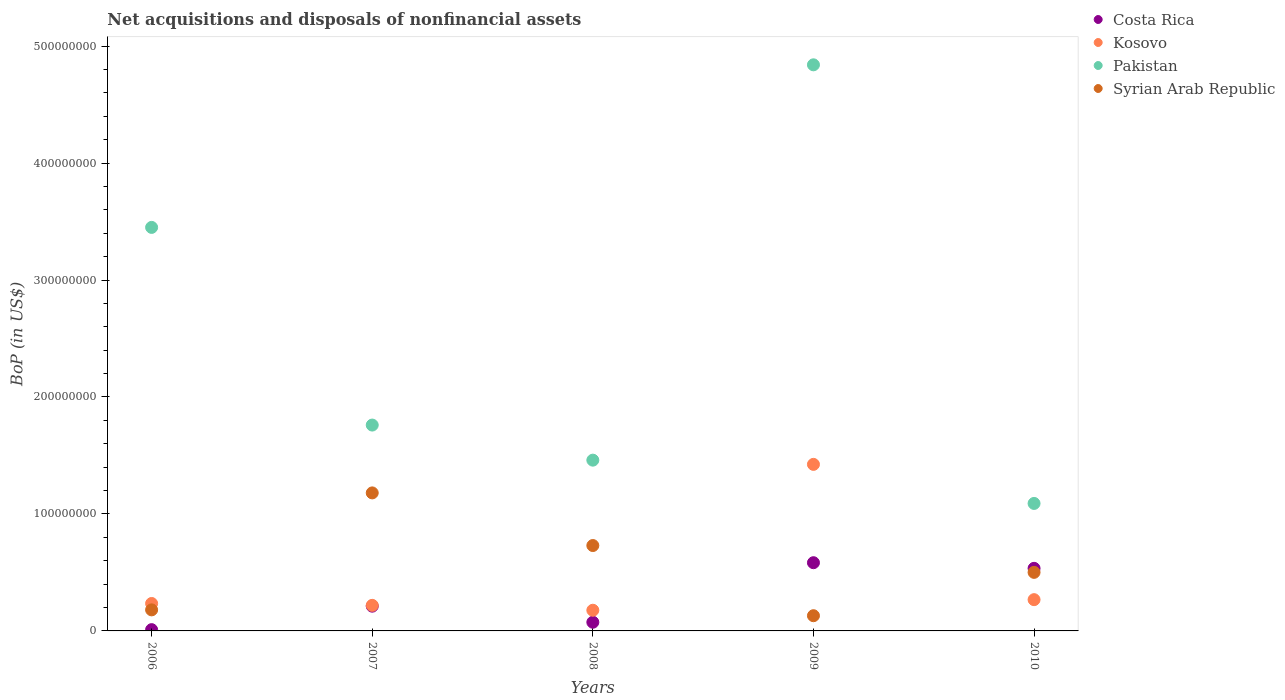How many different coloured dotlines are there?
Give a very brief answer. 4. What is the Balance of Payments in Syrian Arab Republic in 2006?
Offer a terse response. 1.80e+07. Across all years, what is the maximum Balance of Payments in Syrian Arab Republic?
Keep it short and to the point. 1.18e+08. Across all years, what is the minimum Balance of Payments in Pakistan?
Your response must be concise. 1.09e+08. In which year was the Balance of Payments in Pakistan minimum?
Your answer should be very brief. 2010. What is the total Balance of Payments in Syrian Arab Republic in the graph?
Provide a succinct answer. 2.72e+08. What is the difference between the Balance of Payments in Pakistan in 2006 and that in 2008?
Offer a very short reply. 1.99e+08. What is the difference between the Balance of Payments in Syrian Arab Republic in 2009 and the Balance of Payments in Costa Rica in 2007?
Provide a succinct answer. -8.17e+06. What is the average Balance of Payments in Pakistan per year?
Offer a terse response. 2.52e+08. In the year 2007, what is the difference between the Balance of Payments in Kosovo and Balance of Payments in Syrian Arab Republic?
Provide a short and direct response. -9.61e+07. In how many years, is the Balance of Payments in Pakistan greater than 440000000 US$?
Make the answer very short. 1. What is the ratio of the Balance of Payments in Pakistan in 2006 to that in 2008?
Give a very brief answer. 2.36. Is the Balance of Payments in Costa Rica in 2006 less than that in 2007?
Provide a short and direct response. Yes. What is the difference between the highest and the second highest Balance of Payments in Pakistan?
Ensure brevity in your answer.  1.39e+08. What is the difference between the highest and the lowest Balance of Payments in Costa Rica?
Offer a very short reply. 5.72e+07. Is the sum of the Balance of Payments in Costa Rica in 2008 and 2009 greater than the maximum Balance of Payments in Kosovo across all years?
Provide a succinct answer. No. Is it the case that in every year, the sum of the Balance of Payments in Kosovo and Balance of Payments in Costa Rica  is greater than the sum of Balance of Payments in Pakistan and Balance of Payments in Syrian Arab Republic?
Ensure brevity in your answer.  No. How many dotlines are there?
Offer a terse response. 4. Does the graph contain any zero values?
Your answer should be compact. No. Where does the legend appear in the graph?
Offer a very short reply. Top right. How many legend labels are there?
Make the answer very short. 4. How are the legend labels stacked?
Provide a succinct answer. Vertical. What is the title of the graph?
Your answer should be compact. Net acquisitions and disposals of nonfinancial assets. Does "Other small states" appear as one of the legend labels in the graph?
Give a very brief answer. No. What is the label or title of the X-axis?
Offer a very short reply. Years. What is the label or title of the Y-axis?
Give a very brief answer. BoP (in US$). What is the BoP (in US$) of Costa Rica in 2006?
Make the answer very short. 1.09e+06. What is the BoP (in US$) in Kosovo in 2006?
Give a very brief answer. 2.35e+07. What is the BoP (in US$) in Pakistan in 2006?
Keep it short and to the point. 3.45e+08. What is the BoP (in US$) of Syrian Arab Republic in 2006?
Provide a short and direct response. 1.80e+07. What is the BoP (in US$) in Costa Rica in 2007?
Your answer should be very brief. 2.12e+07. What is the BoP (in US$) in Kosovo in 2007?
Your answer should be very brief. 2.19e+07. What is the BoP (in US$) in Pakistan in 2007?
Your response must be concise. 1.76e+08. What is the BoP (in US$) in Syrian Arab Republic in 2007?
Your answer should be very brief. 1.18e+08. What is the BoP (in US$) of Costa Rica in 2008?
Your response must be concise. 7.42e+06. What is the BoP (in US$) of Kosovo in 2008?
Offer a very short reply. 1.77e+07. What is the BoP (in US$) of Pakistan in 2008?
Your answer should be very brief. 1.46e+08. What is the BoP (in US$) in Syrian Arab Republic in 2008?
Make the answer very short. 7.30e+07. What is the BoP (in US$) in Costa Rica in 2009?
Your answer should be compact. 5.83e+07. What is the BoP (in US$) of Kosovo in 2009?
Provide a short and direct response. 1.42e+08. What is the BoP (in US$) of Pakistan in 2009?
Your response must be concise. 4.84e+08. What is the BoP (in US$) in Syrian Arab Republic in 2009?
Keep it short and to the point. 1.30e+07. What is the BoP (in US$) of Costa Rica in 2010?
Your answer should be very brief. 5.35e+07. What is the BoP (in US$) of Kosovo in 2010?
Your response must be concise. 2.67e+07. What is the BoP (in US$) in Pakistan in 2010?
Offer a very short reply. 1.09e+08. What is the BoP (in US$) of Syrian Arab Republic in 2010?
Offer a terse response. 5.01e+07. Across all years, what is the maximum BoP (in US$) of Costa Rica?
Keep it short and to the point. 5.83e+07. Across all years, what is the maximum BoP (in US$) of Kosovo?
Provide a succinct answer. 1.42e+08. Across all years, what is the maximum BoP (in US$) in Pakistan?
Your answer should be compact. 4.84e+08. Across all years, what is the maximum BoP (in US$) of Syrian Arab Republic?
Your answer should be very brief. 1.18e+08. Across all years, what is the minimum BoP (in US$) in Costa Rica?
Offer a very short reply. 1.09e+06. Across all years, what is the minimum BoP (in US$) of Kosovo?
Keep it short and to the point. 1.77e+07. Across all years, what is the minimum BoP (in US$) in Pakistan?
Give a very brief answer. 1.09e+08. Across all years, what is the minimum BoP (in US$) in Syrian Arab Republic?
Give a very brief answer. 1.30e+07. What is the total BoP (in US$) in Costa Rica in the graph?
Your answer should be compact. 1.41e+08. What is the total BoP (in US$) of Kosovo in the graph?
Your answer should be very brief. 2.32e+08. What is the total BoP (in US$) in Pakistan in the graph?
Ensure brevity in your answer.  1.26e+09. What is the total BoP (in US$) in Syrian Arab Republic in the graph?
Offer a very short reply. 2.72e+08. What is the difference between the BoP (in US$) in Costa Rica in 2006 and that in 2007?
Offer a very short reply. -2.01e+07. What is the difference between the BoP (in US$) of Kosovo in 2006 and that in 2007?
Your response must be concise. 1.60e+06. What is the difference between the BoP (in US$) in Pakistan in 2006 and that in 2007?
Your answer should be very brief. 1.69e+08. What is the difference between the BoP (in US$) in Syrian Arab Republic in 2006 and that in 2007?
Make the answer very short. -1.00e+08. What is the difference between the BoP (in US$) in Costa Rica in 2006 and that in 2008?
Your response must be concise. -6.33e+06. What is the difference between the BoP (in US$) in Kosovo in 2006 and that in 2008?
Your answer should be compact. 5.78e+06. What is the difference between the BoP (in US$) in Pakistan in 2006 and that in 2008?
Your answer should be very brief. 1.99e+08. What is the difference between the BoP (in US$) of Syrian Arab Republic in 2006 and that in 2008?
Ensure brevity in your answer.  -5.50e+07. What is the difference between the BoP (in US$) in Costa Rica in 2006 and that in 2009?
Ensure brevity in your answer.  -5.72e+07. What is the difference between the BoP (in US$) of Kosovo in 2006 and that in 2009?
Offer a terse response. -1.19e+08. What is the difference between the BoP (in US$) in Pakistan in 2006 and that in 2009?
Your answer should be compact. -1.39e+08. What is the difference between the BoP (in US$) of Costa Rica in 2006 and that in 2010?
Provide a succinct answer. -5.24e+07. What is the difference between the BoP (in US$) in Kosovo in 2006 and that in 2010?
Give a very brief answer. -3.27e+06. What is the difference between the BoP (in US$) of Pakistan in 2006 and that in 2010?
Provide a short and direct response. 2.36e+08. What is the difference between the BoP (in US$) of Syrian Arab Republic in 2006 and that in 2010?
Keep it short and to the point. -3.21e+07. What is the difference between the BoP (in US$) of Costa Rica in 2007 and that in 2008?
Your answer should be compact. 1.37e+07. What is the difference between the BoP (in US$) in Kosovo in 2007 and that in 2008?
Give a very brief answer. 4.18e+06. What is the difference between the BoP (in US$) in Pakistan in 2007 and that in 2008?
Make the answer very short. 3.00e+07. What is the difference between the BoP (in US$) of Syrian Arab Republic in 2007 and that in 2008?
Offer a terse response. 4.50e+07. What is the difference between the BoP (in US$) of Costa Rica in 2007 and that in 2009?
Your answer should be very brief. -3.72e+07. What is the difference between the BoP (in US$) in Kosovo in 2007 and that in 2009?
Offer a terse response. -1.21e+08. What is the difference between the BoP (in US$) of Pakistan in 2007 and that in 2009?
Your answer should be compact. -3.08e+08. What is the difference between the BoP (in US$) in Syrian Arab Republic in 2007 and that in 2009?
Provide a succinct answer. 1.05e+08. What is the difference between the BoP (in US$) of Costa Rica in 2007 and that in 2010?
Your response must be concise. -3.23e+07. What is the difference between the BoP (in US$) in Kosovo in 2007 and that in 2010?
Your answer should be very brief. -4.87e+06. What is the difference between the BoP (in US$) of Pakistan in 2007 and that in 2010?
Your answer should be very brief. 6.70e+07. What is the difference between the BoP (in US$) of Syrian Arab Republic in 2007 and that in 2010?
Offer a very short reply. 6.79e+07. What is the difference between the BoP (in US$) of Costa Rica in 2008 and that in 2009?
Provide a succinct answer. -5.09e+07. What is the difference between the BoP (in US$) in Kosovo in 2008 and that in 2009?
Offer a terse response. -1.25e+08. What is the difference between the BoP (in US$) of Pakistan in 2008 and that in 2009?
Provide a short and direct response. -3.38e+08. What is the difference between the BoP (in US$) in Syrian Arab Republic in 2008 and that in 2009?
Offer a terse response. 6.00e+07. What is the difference between the BoP (in US$) in Costa Rica in 2008 and that in 2010?
Provide a short and direct response. -4.61e+07. What is the difference between the BoP (in US$) of Kosovo in 2008 and that in 2010?
Offer a terse response. -9.06e+06. What is the difference between the BoP (in US$) in Pakistan in 2008 and that in 2010?
Make the answer very short. 3.70e+07. What is the difference between the BoP (in US$) in Syrian Arab Republic in 2008 and that in 2010?
Provide a short and direct response. 2.29e+07. What is the difference between the BoP (in US$) of Costa Rica in 2009 and that in 2010?
Provide a short and direct response. 4.81e+06. What is the difference between the BoP (in US$) of Kosovo in 2009 and that in 2010?
Your answer should be compact. 1.16e+08. What is the difference between the BoP (in US$) of Pakistan in 2009 and that in 2010?
Your answer should be very brief. 3.75e+08. What is the difference between the BoP (in US$) in Syrian Arab Republic in 2009 and that in 2010?
Ensure brevity in your answer.  -3.71e+07. What is the difference between the BoP (in US$) of Costa Rica in 2006 and the BoP (in US$) of Kosovo in 2007?
Give a very brief answer. -2.08e+07. What is the difference between the BoP (in US$) of Costa Rica in 2006 and the BoP (in US$) of Pakistan in 2007?
Ensure brevity in your answer.  -1.75e+08. What is the difference between the BoP (in US$) in Costa Rica in 2006 and the BoP (in US$) in Syrian Arab Republic in 2007?
Your answer should be very brief. -1.17e+08. What is the difference between the BoP (in US$) in Kosovo in 2006 and the BoP (in US$) in Pakistan in 2007?
Ensure brevity in your answer.  -1.53e+08. What is the difference between the BoP (in US$) of Kosovo in 2006 and the BoP (in US$) of Syrian Arab Republic in 2007?
Offer a very short reply. -9.45e+07. What is the difference between the BoP (in US$) in Pakistan in 2006 and the BoP (in US$) in Syrian Arab Republic in 2007?
Offer a terse response. 2.27e+08. What is the difference between the BoP (in US$) in Costa Rica in 2006 and the BoP (in US$) in Kosovo in 2008?
Ensure brevity in your answer.  -1.66e+07. What is the difference between the BoP (in US$) of Costa Rica in 2006 and the BoP (in US$) of Pakistan in 2008?
Ensure brevity in your answer.  -1.45e+08. What is the difference between the BoP (in US$) in Costa Rica in 2006 and the BoP (in US$) in Syrian Arab Republic in 2008?
Ensure brevity in your answer.  -7.19e+07. What is the difference between the BoP (in US$) in Kosovo in 2006 and the BoP (in US$) in Pakistan in 2008?
Offer a very short reply. -1.23e+08. What is the difference between the BoP (in US$) in Kosovo in 2006 and the BoP (in US$) in Syrian Arab Republic in 2008?
Keep it short and to the point. -4.95e+07. What is the difference between the BoP (in US$) of Pakistan in 2006 and the BoP (in US$) of Syrian Arab Republic in 2008?
Your response must be concise. 2.72e+08. What is the difference between the BoP (in US$) in Costa Rica in 2006 and the BoP (in US$) in Kosovo in 2009?
Provide a short and direct response. -1.41e+08. What is the difference between the BoP (in US$) of Costa Rica in 2006 and the BoP (in US$) of Pakistan in 2009?
Your response must be concise. -4.83e+08. What is the difference between the BoP (in US$) in Costa Rica in 2006 and the BoP (in US$) in Syrian Arab Republic in 2009?
Make the answer very short. -1.19e+07. What is the difference between the BoP (in US$) of Kosovo in 2006 and the BoP (in US$) of Pakistan in 2009?
Your response must be concise. -4.61e+08. What is the difference between the BoP (in US$) of Kosovo in 2006 and the BoP (in US$) of Syrian Arab Republic in 2009?
Offer a very short reply. 1.05e+07. What is the difference between the BoP (in US$) of Pakistan in 2006 and the BoP (in US$) of Syrian Arab Republic in 2009?
Make the answer very short. 3.32e+08. What is the difference between the BoP (in US$) of Costa Rica in 2006 and the BoP (in US$) of Kosovo in 2010?
Give a very brief answer. -2.56e+07. What is the difference between the BoP (in US$) of Costa Rica in 2006 and the BoP (in US$) of Pakistan in 2010?
Ensure brevity in your answer.  -1.08e+08. What is the difference between the BoP (in US$) of Costa Rica in 2006 and the BoP (in US$) of Syrian Arab Republic in 2010?
Your answer should be very brief. -4.90e+07. What is the difference between the BoP (in US$) of Kosovo in 2006 and the BoP (in US$) of Pakistan in 2010?
Offer a very short reply. -8.55e+07. What is the difference between the BoP (in US$) of Kosovo in 2006 and the BoP (in US$) of Syrian Arab Republic in 2010?
Keep it short and to the point. -2.66e+07. What is the difference between the BoP (in US$) of Pakistan in 2006 and the BoP (in US$) of Syrian Arab Republic in 2010?
Offer a terse response. 2.95e+08. What is the difference between the BoP (in US$) in Costa Rica in 2007 and the BoP (in US$) in Kosovo in 2008?
Make the answer very short. 3.49e+06. What is the difference between the BoP (in US$) in Costa Rica in 2007 and the BoP (in US$) in Pakistan in 2008?
Give a very brief answer. -1.25e+08. What is the difference between the BoP (in US$) in Costa Rica in 2007 and the BoP (in US$) in Syrian Arab Republic in 2008?
Make the answer very short. -5.18e+07. What is the difference between the BoP (in US$) of Kosovo in 2007 and the BoP (in US$) of Pakistan in 2008?
Your answer should be compact. -1.24e+08. What is the difference between the BoP (in US$) of Kosovo in 2007 and the BoP (in US$) of Syrian Arab Republic in 2008?
Provide a succinct answer. -5.11e+07. What is the difference between the BoP (in US$) in Pakistan in 2007 and the BoP (in US$) in Syrian Arab Republic in 2008?
Offer a very short reply. 1.03e+08. What is the difference between the BoP (in US$) in Costa Rica in 2007 and the BoP (in US$) in Kosovo in 2009?
Provide a succinct answer. -1.21e+08. What is the difference between the BoP (in US$) in Costa Rica in 2007 and the BoP (in US$) in Pakistan in 2009?
Ensure brevity in your answer.  -4.63e+08. What is the difference between the BoP (in US$) of Costa Rica in 2007 and the BoP (in US$) of Syrian Arab Republic in 2009?
Your answer should be very brief. 8.17e+06. What is the difference between the BoP (in US$) in Kosovo in 2007 and the BoP (in US$) in Pakistan in 2009?
Keep it short and to the point. -4.62e+08. What is the difference between the BoP (in US$) of Kosovo in 2007 and the BoP (in US$) of Syrian Arab Republic in 2009?
Provide a short and direct response. 8.86e+06. What is the difference between the BoP (in US$) in Pakistan in 2007 and the BoP (in US$) in Syrian Arab Republic in 2009?
Your answer should be compact. 1.63e+08. What is the difference between the BoP (in US$) in Costa Rica in 2007 and the BoP (in US$) in Kosovo in 2010?
Your answer should be compact. -5.56e+06. What is the difference between the BoP (in US$) in Costa Rica in 2007 and the BoP (in US$) in Pakistan in 2010?
Keep it short and to the point. -8.78e+07. What is the difference between the BoP (in US$) of Costa Rica in 2007 and the BoP (in US$) of Syrian Arab Republic in 2010?
Your answer should be compact. -2.89e+07. What is the difference between the BoP (in US$) in Kosovo in 2007 and the BoP (in US$) in Pakistan in 2010?
Your response must be concise. -8.71e+07. What is the difference between the BoP (in US$) in Kosovo in 2007 and the BoP (in US$) in Syrian Arab Republic in 2010?
Make the answer very short. -2.82e+07. What is the difference between the BoP (in US$) in Pakistan in 2007 and the BoP (in US$) in Syrian Arab Republic in 2010?
Provide a succinct answer. 1.26e+08. What is the difference between the BoP (in US$) of Costa Rica in 2008 and the BoP (in US$) of Kosovo in 2009?
Offer a very short reply. -1.35e+08. What is the difference between the BoP (in US$) of Costa Rica in 2008 and the BoP (in US$) of Pakistan in 2009?
Give a very brief answer. -4.77e+08. What is the difference between the BoP (in US$) in Costa Rica in 2008 and the BoP (in US$) in Syrian Arab Republic in 2009?
Offer a terse response. -5.58e+06. What is the difference between the BoP (in US$) of Kosovo in 2008 and the BoP (in US$) of Pakistan in 2009?
Your response must be concise. -4.66e+08. What is the difference between the BoP (in US$) in Kosovo in 2008 and the BoP (in US$) in Syrian Arab Republic in 2009?
Keep it short and to the point. 4.67e+06. What is the difference between the BoP (in US$) in Pakistan in 2008 and the BoP (in US$) in Syrian Arab Republic in 2009?
Offer a very short reply. 1.33e+08. What is the difference between the BoP (in US$) of Costa Rica in 2008 and the BoP (in US$) of Kosovo in 2010?
Provide a succinct answer. -1.93e+07. What is the difference between the BoP (in US$) in Costa Rica in 2008 and the BoP (in US$) in Pakistan in 2010?
Offer a very short reply. -1.02e+08. What is the difference between the BoP (in US$) in Costa Rica in 2008 and the BoP (in US$) in Syrian Arab Republic in 2010?
Keep it short and to the point. -4.26e+07. What is the difference between the BoP (in US$) of Kosovo in 2008 and the BoP (in US$) of Pakistan in 2010?
Your response must be concise. -9.13e+07. What is the difference between the BoP (in US$) in Kosovo in 2008 and the BoP (in US$) in Syrian Arab Republic in 2010?
Keep it short and to the point. -3.24e+07. What is the difference between the BoP (in US$) in Pakistan in 2008 and the BoP (in US$) in Syrian Arab Republic in 2010?
Give a very brief answer. 9.59e+07. What is the difference between the BoP (in US$) in Costa Rica in 2009 and the BoP (in US$) in Kosovo in 2010?
Your answer should be compact. 3.16e+07. What is the difference between the BoP (in US$) of Costa Rica in 2009 and the BoP (in US$) of Pakistan in 2010?
Your answer should be compact. -5.07e+07. What is the difference between the BoP (in US$) in Costa Rica in 2009 and the BoP (in US$) in Syrian Arab Republic in 2010?
Provide a succinct answer. 8.26e+06. What is the difference between the BoP (in US$) of Kosovo in 2009 and the BoP (in US$) of Pakistan in 2010?
Offer a terse response. 3.34e+07. What is the difference between the BoP (in US$) of Kosovo in 2009 and the BoP (in US$) of Syrian Arab Republic in 2010?
Keep it short and to the point. 9.23e+07. What is the difference between the BoP (in US$) of Pakistan in 2009 and the BoP (in US$) of Syrian Arab Republic in 2010?
Give a very brief answer. 4.34e+08. What is the average BoP (in US$) of Costa Rica per year?
Your answer should be very brief. 2.83e+07. What is the average BoP (in US$) of Kosovo per year?
Provide a succinct answer. 4.64e+07. What is the average BoP (in US$) in Pakistan per year?
Offer a terse response. 2.52e+08. What is the average BoP (in US$) of Syrian Arab Republic per year?
Your answer should be compact. 5.44e+07. In the year 2006, what is the difference between the BoP (in US$) of Costa Rica and BoP (in US$) of Kosovo?
Keep it short and to the point. -2.24e+07. In the year 2006, what is the difference between the BoP (in US$) of Costa Rica and BoP (in US$) of Pakistan?
Keep it short and to the point. -3.44e+08. In the year 2006, what is the difference between the BoP (in US$) of Costa Rica and BoP (in US$) of Syrian Arab Republic?
Provide a short and direct response. -1.69e+07. In the year 2006, what is the difference between the BoP (in US$) of Kosovo and BoP (in US$) of Pakistan?
Your response must be concise. -3.22e+08. In the year 2006, what is the difference between the BoP (in US$) in Kosovo and BoP (in US$) in Syrian Arab Republic?
Offer a very short reply. 5.46e+06. In the year 2006, what is the difference between the BoP (in US$) of Pakistan and BoP (in US$) of Syrian Arab Republic?
Provide a short and direct response. 3.27e+08. In the year 2007, what is the difference between the BoP (in US$) of Costa Rica and BoP (in US$) of Kosovo?
Your answer should be very brief. -6.90e+05. In the year 2007, what is the difference between the BoP (in US$) in Costa Rica and BoP (in US$) in Pakistan?
Offer a very short reply. -1.55e+08. In the year 2007, what is the difference between the BoP (in US$) of Costa Rica and BoP (in US$) of Syrian Arab Republic?
Your answer should be very brief. -9.68e+07. In the year 2007, what is the difference between the BoP (in US$) in Kosovo and BoP (in US$) in Pakistan?
Offer a terse response. -1.54e+08. In the year 2007, what is the difference between the BoP (in US$) in Kosovo and BoP (in US$) in Syrian Arab Republic?
Your response must be concise. -9.61e+07. In the year 2007, what is the difference between the BoP (in US$) of Pakistan and BoP (in US$) of Syrian Arab Republic?
Offer a very short reply. 5.80e+07. In the year 2008, what is the difference between the BoP (in US$) in Costa Rica and BoP (in US$) in Kosovo?
Ensure brevity in your answer.  -1.03e+07. In the year 2008, what is the difference between the BoP (in US$) in Costa Rica and BoP (in US$) in Pakistan?
Provide a succinct answer. -1.39e+08. In the year 2008, what is the difference between the BoP (in US$) of Costa Rica and BoP (in US$) of Syrian Arab Republic?
Make the answer very short. -6.56e+07. In the year 2008, what is the difference between the BoP (in US$) in Kosovo and BoP (in US$) in Pakistan?
Keep it short and to the point. -1.28e+08. In the year 2008, what is the difference between the BoP (in US$) of Kosovo and BoP (in US$) of Syrian Arab Republic?
Offer a very short reply. -5.53e+07. In the year 2008, what is the difference between the BoP (in US$) in Pakistan and BoP (in US$) in Syrian Arab Republic?
Your response must be concise. 7.30e+07. In the year 2009, what is the difference between the BoP (in US$) in Costa Rica and BoP (in US$) in Kosovo?
Your answer should be very brief. -8.41e+07. In the year 2009, what is the difference between the BoP (in US$) of Costa Rica and BoP (in US$) of Pakistan?
Make the answer very short. -4.26e+08. In the year 2009, what is the difference between the BoP (in US$) of Costa Rica and BoP (in US$) of Syrian Arab Republic?
Provide a succinct answer. 4.53e+07. In the year 2009, what is the difference between the BoP (in US$) of Kosovo and BoP (in US$) of Pakistan?
Your answer should be compact. -3.42e+08. In the year 2009, what is the difference between the BoP (in US$) in Kosovo and BoP (in US$) in Syrian Arab Republic?
Make the answer very short. 1.29e+08. In the year 2009, what is the difference between the BoP (in US$) in Pakistan and BoP (in US$) in Syrian Arab Republic?
Give a very brief answer. 4.71e+08. In the year 2010, what is the difference between the BoP (in US$) of Costa Rica and BoP (in US$) of Kosovo?
Provide a short and direct response. 2.68e+07. In the year 2010, what is the difference between the BoP (in US$) in Costa Rica and BoP (in US$) in Pakistan?
Provide a succinct answer. -5.55e+07. In the year 2010, what is the difference between the BoP (in US$) of Costa Rica and BoP (in US$) of Syrian Arab Republic?
Make the answer very short. 3.44e+06. In the year 2010, what is the difference between the BoP (in US$) in Kosovo and BoP (in US$) in Pakistan?
Your answer should be very brief. -8.23e+07. In the year 2010, what is the difference between the BoP (in US$) of Kosovo and BoP (in US$) of Syrian Arab Republic?
Provide a succinct answer. -2.33e+07. In the year 2010, what is the difference between the BoP (in US$) of Pakistan and BoP (in US$) of Syrian Arab Republic?
Provide a short and direct response. 5.89e+07. What is the ratio of the BoP (in US$) of Costa Rica in 2006 to that in 2007?
Provide a short and direct response. 0.05. What is the ratio of the BoP (in US$) of Kosovo in 2006 to that in 2007?
Your answer should be compact. 1.07. What is the ratio of the BoP (in US$) of Pakistan in 2006 to that in 2007?
Make the answer very short. 1.96. What is the ratio of the BoP (in US$) of Syrian Arab Republic in 2006 to that in 2007?
Your response must be concise. 0.15. What is the ratio of the BoP (in US$) in Costa Rica in 2006 to that in 2008?
Your answer should be compact. 0.15. What is the ratio of the BoP (in US$) in Kosovo in 2006 to that in 2008?
Your answer should be compact. 1.33. What is the ratio of the BoP (in US$) of Pakistan in 2006 to that in 2008?
Offer a very short reply. 2.36. What is the ratio of the BoP (in US$) of Syrian Arab Republic in 2006 to that in 2008?
Provide a succinct answer. 0.25. What is the ratio of the BoP (in US$) of Costa Rica in 2006 to that in 2009?
Your response must be concise. 0.02. What is the ratio of the BoP (in US$) in Kosovo in 2006 to that in 2009?
Provide a short and direct response. 0.16. What is the ratio of the BoP (in US$) of Pakistan in 2006 to that in 2009?
Give a very brief answer. 0.71. What is the ratio of the BoP (in US$) of Syrian Arab Republic in 2006 to that in 2009?
Keep it short and to the point. 1.38. What is the ratio of the BoP (in US$) in Costa Rica in 2006 to that in 2010?
Give a very brief answer. 0.02. What is the ratio of the BoP (in US$) of Kosovo in 2006 to that in 2010?
Give a very brief answer. 0.88. What is the ratio of the BoP (in US$) in Pakistan in 2006 to that in 2010?
Your answer should be compact. 3.17. What is the ratio of the BoP (in US$) of Syrian Arab Republic in 2006 to that in 2010?
Offer a very short reply. 0.36. What is the ratio of the BoP (in US$) in Costa Rica in 2007 to that in 2008?
Your answer should be very brief. 2.85. What is the ratio of the BoP (in US$) in Kosovo in 2007 to that in 2008?
Your answer should be compact. 1.24. What is the ratio of the BoP (in US$) in Pakistan in 2007 to that in 2008?
Keep it short and to the point. 1.21. What is the ratio of the BoP (in US$) in Syrian Arab Republic in 2007 to that in 2008?
Keep it short and to the point. 1.62. What is the ratio of the BoP (in US$) in Costa Rica in 2007 to that in 2009?
Keep it short and to the point. 0.36. What is the ratio of the BoP (in US$) of Kosovo in 2007 to that in 2009?
Give a very brief answer. 0.15. What is the ratio of the BoP (in US$) of Pakistan in 2007 to that in 2009?
Make the answer very short. 0.36. What is the ratio of the BoP (in US$) of Syrian Arab Republic in 2007 to that in 2009?
Your response must be concise. 9.08. What is the ratio of the BoP (in US$) in Costa Rica in 2007 to that in 2010?
Your answer should be compact. 0.4. What is the ratio of the BoP (in US$) in Kosovo in 2007 to that in 2010?
Make the answer very short. 0.82. What is the ratio of the BoP (in US$) in Pakistan in 2007 to that in 2010?
Ensure brevity in your answer.  1.61. What is the ratio of the BoP (in US$) in Syrian Arab Republic in 2007 to that in 2010?
Provide a succinct answer. 2.36. What is the ratio of the BoP (in US$) in Costa Rica in 2008 to that in 2009?
Ensure brevity in your answer.  0.13. What is the ratio of the BoP (in US$) of Kosovo in 2008 to that in 2009?
Your answer should be compact. 0.12. What is the ratio of the BoP (in US$) in Pakistan in 2008 to that in 2009?
Provide a short and direct response. 0.3. What is the ratio of the BoP (in US$) of Syrian Arab Republic in 2008 to that in 2009?
Your response must be concise. 5.62. What is the ratio of the BoP (in US$) in Costa Rica in 2008 to that in 2010?
Make the answer very short. 0.14. What is the ratio of the BoP (in US$) in Kosovo in 2008 to that in 2010?
Your response must be concise. 0.66. What is the ratio of the BoP (in US$) in Pakistan in 2008 to that in 2010?
Keep it short and to the point. 1.34. What is the ratio of the BoP (in US$) of Syrian Arab Republic in 2008 to that in 2010?
Keep it short and to the point. 1.46. What is the ratio of the BoP (in US$) in Costa Rica in 2009 to that in 2010?
Offer a terse response. 1.09. What is the ratio of the BoP (in US$) in Kosovo in 2009 to that in 2010?
Provide a succinct answer. 5.33. What is the ratio of the BoP (in US$) of Pakistan in 2009 to that in 2010?
Give a very brief answer. 4.44. What is the ratio of the BoP (in US$) in Syrian Arab Republic in 2009 to that in 2010?
Keep it short and to the point. 0.26. What is the difference between the highest and the second highest BoP (in US$) of Costa Rica?
Keep it short and to the point. 4.81e+06. What is the difference between the highest and the second highest BoP (in US$) of Kosovo?
Your answer should be very brief. 1.16e+08. What is the difference between the highest and the second highest BoP (in US$) in Pakistan?
Provide a succinct answer. 1.39e+08. What is the difference between the highest and the second highest BoP (in US$) in Syrian Arab Republic?
Ensure brevity in your answer.  4.50e+07. What is the difference between the highest and the lowest BoP (in US$) in Costa Rica?
Keep it short and to the point. 5.72e+07. What is the difference between the highest and the lowest BoP (in US$) in Kosovo?
Your answer should be very brief. 1.25e+08. What is the difference between the highest and the lowest BoP (in US$) of Pakistan?
Your answer should be very brief. 3.75e+08. What is the difference between the highest and the lowest BoP (in US$) in Syrian Arab Republic?
Keep it short and to the point. 1.05e+08. 